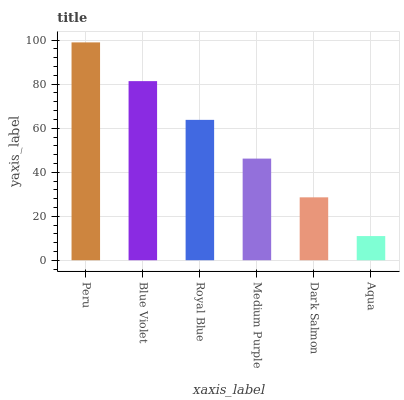Is Aqua the minimum?
Answer yes or no. Yes. Is Peru the maximum?
Answer yes or no. Yes. Is Blue Violet the minimum?
Answer yes or no. No. Is Blue Violet the maximum?
Answer yes or no. No. Is Peru greater than Blue Violet?
Answer yes or no. Yes. Is Blue Violet less than Peru?
Answer yes or no. Yes. Is Blue Violet greater than Peru?
Answer yes or no. No. Is Peru less than Blue Violet?
Answer yes or no. No. Is Royal Blue the high median?
Answer yes or no. Yes. Is Medium Purple the low median?
Answer yes or no. Yes. Is Blue Violet the high median?
Answer yes or no. No. Is Blue Violet the low median?
Answer yes or no. No. 